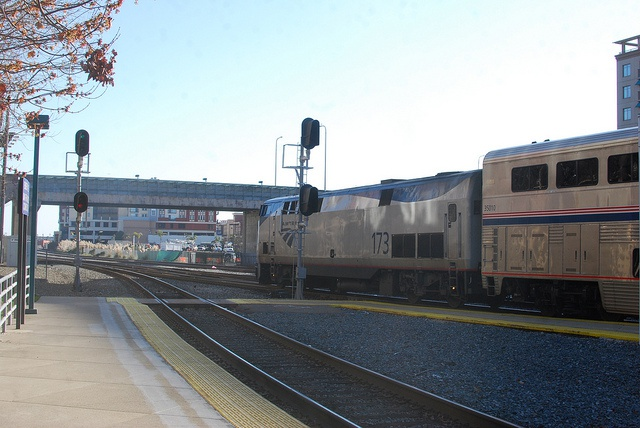Describe the objects in this image and their specific colors. I can see train in gray, black, and darkgray tones, traffic light in gray, darkblue, and white tones, traffic light in gray, black, navy, and darkblue tones, traffic light in gray, blue, black, and purple tones, and traffic light in gray, black, and maroon tones in this image. 